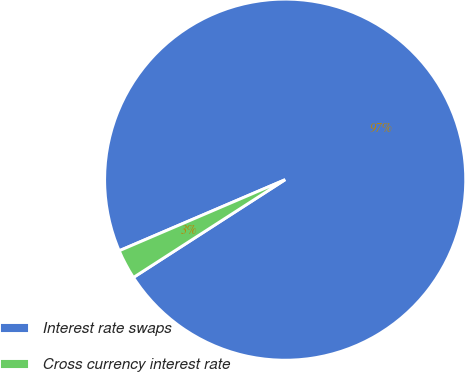Convert chart. <chart><loc_0><loc_0><loc_500><loc_500><pie_chart><fcel>Interest rate swaps<fcel>Cross currency interest rate<nl><fcel>97.33%<fcel>2.67%<nl></chart> 